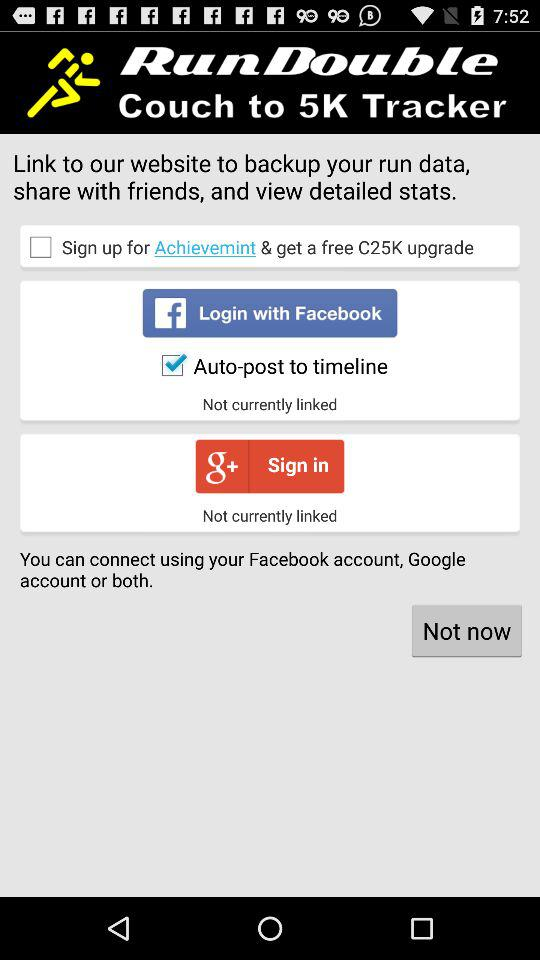Through which applications can we log in? You can log in through "Facebook" and "Google+". 